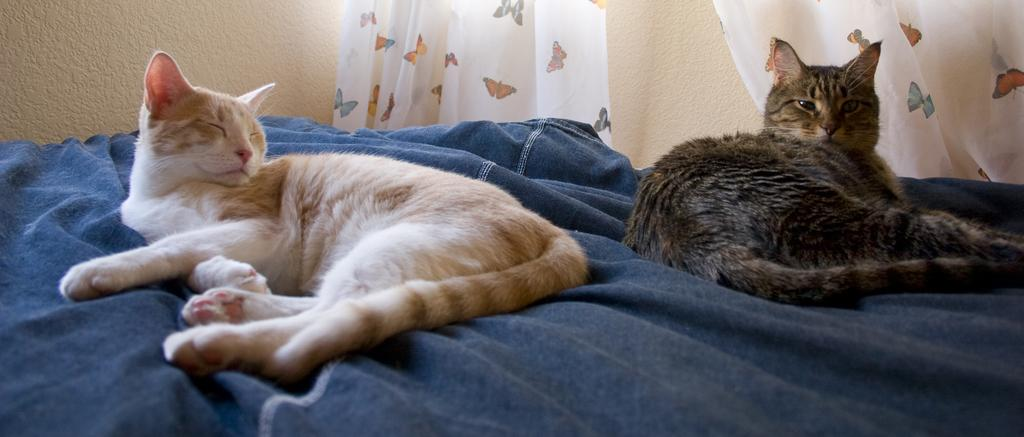What animals are lying on the bed in the image? There are cats lying on the bed in the image. What type of window treatment is present in the image? There are curtains in the image. What type of debt is being discussed in the image? There is no mention of debt in the image; it features cats lying on a bed and curtains. Where is the park located in the image? There is no park present in the image. 